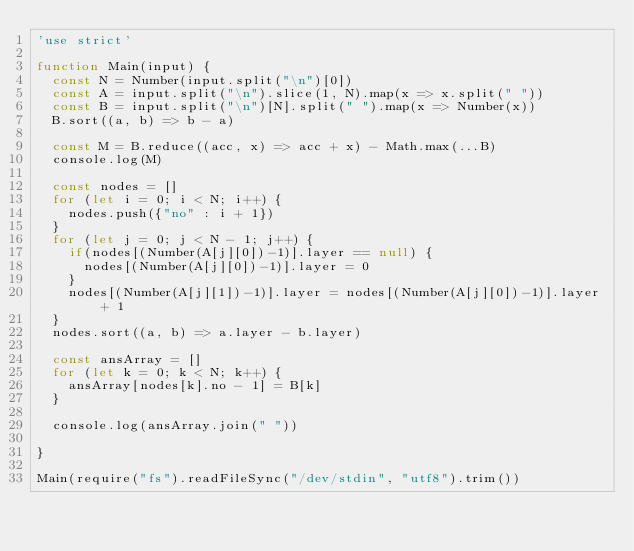Convert code to text. <code><loc_0><loc_0><loc_500><loc_500><_JavaScript_>'use strict'

function Main(input) {
  const N = Number(input.split("\n")[0])
  const A = input.split("\n").slice(1, N).map(x => x.split(" "))
  const B = input.split("\n")[N].split(" ").map(x => Number(x))
  B.sort((a, b) => b - a)

  const M = B.reduce((acc, x) => acc + x) - Math.max(...B)
  console.log(M)

  const nodes = []
  for (let i = 0; i < N; i++) {
    nodes.push({"no" : i + 1})
  }
  for (let j = 0; j < N - 1; j++) {
    if(nodes[(Number(A[j][0])-1)].layer == null) {
      nodes[(Number(A[j][0])-1)].layer = 0
    }
    nodes[(Number(A[j][1])-1)].layer = nodes[(Number(A[j][0])-1)].layer + 1
  }
  nodes.sort((a, b) => a.layer - b.layer)
  
  const ansArray = []
  for (let k = 0; k < N; k++) {
    ansArray[nodes[k].no - 1] = B[k]
  }
  
  console.log(ansArray.join(" "))

}

Main(require("fs").readFileSync("/dev/stdin", "utf8").trim())
</code> 